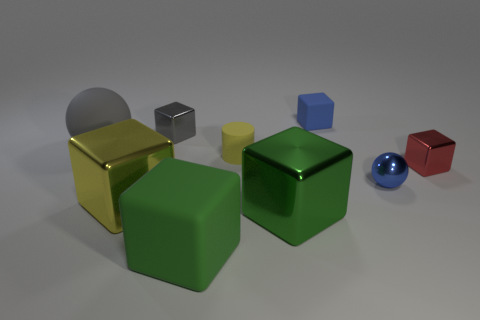Are there any other things that have the same shape as the tiny yellow rubber object?
Provide a short and direct response. No. There is a thing that is in front of the tiny red metal cube and on the right side of the tiny blue matte thing; what is its color?
Offer a terse response. Blue. There is a gray metal thing that is the same size as the red thing; what is its shape?
Give a very brief answer. Cube. Are there any small yellow things of the same shape as the large green matte object?
Provide a short and direct response. No. Do the ball that is left of the rubber cylinder and the tiny red metallic cube have the same size?
Your answer should be compact. No. There is a thing that is both right of the big green rubber thing and in front of the yellow metallic object; what is its size?
Give a very brief answer. Large. How many other things are made of the same material as the tiny yellow cylinder?
Your response must be concise. 3. What is the size of the shiny sphere that is behind the large rubber block?
Offer a very short reply. Small. Do the small matte block and the metallic sphere have the same color?
Offer a very short reply. Yes. What number of tiny things are either gray matte cylinders or gray metal things?
Keep it short and to the point. 1. 